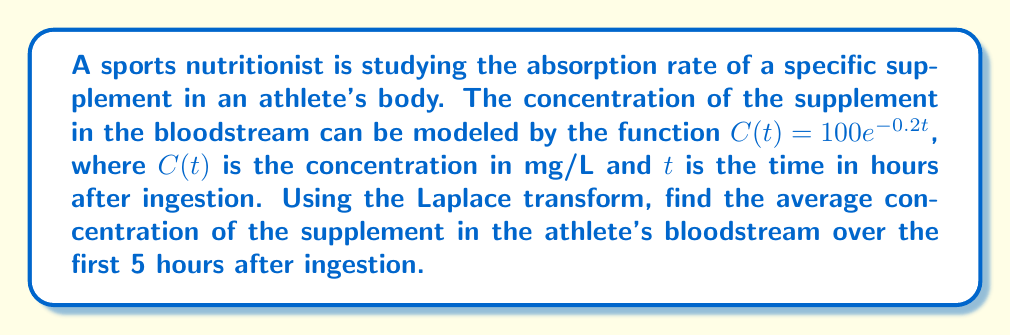Teach me how to tackle this problem. To solve this problem, we'll use the Laplace transform and its properties. Let's break it down step-by-step:

1) The average concentration over the interval $[0, 5]$ is given by:

   $$\frac{1}{5} \int_0^5 C(t) dt$$

2) We need to find $\int_0^5 C(t) dt$ using the Laplace transform. Let's call this integral $I$.

3) The Laplace transform of $C(t)$ is:

   $$\mathcal{L}\{C(t)\} = \mathcal{L}\{100e^{-0.2t}\} = \frac{100}{s + 0.2}$$

4) To find the integral from 0 to 5, we can use the following property:

   $$\int_0^5 f(t) dt = \frac{1}{s}\mathcal{L}\{f(t)\} - \frac{1}{s}\mathcal{L}\{f(t+5)\}$$

5) Therefore:

   $$I = \frac{1}{s}\cdot\frac{100}{s + 0.2} - \frac{1}{s}\cdot\frac{100e^{-5s}}{s + 0.2}$$

6) Taking the inverse Laplace transform:

   $$I = 100\cdot\frac{1 - e^{-0.2\cdot5}}{0.2} = 500(1 - e^{-1})$$

7) Now, we can calculate the average concentration:

   $$\text{Average Concentration} = \frac{1}{5} \cdot 500(1 - e^{-1}) = 100(1 - e^{-1})$$

8) Evaluating this expression:

   $$100(1 - e^{-1}) \approx 63.21 \text{ mg/L}$$
Answer: The average concentration of the supplement in the athlete's bloodstream over the first 5 hours after ingestion is approximately 63.21 mg/L. 